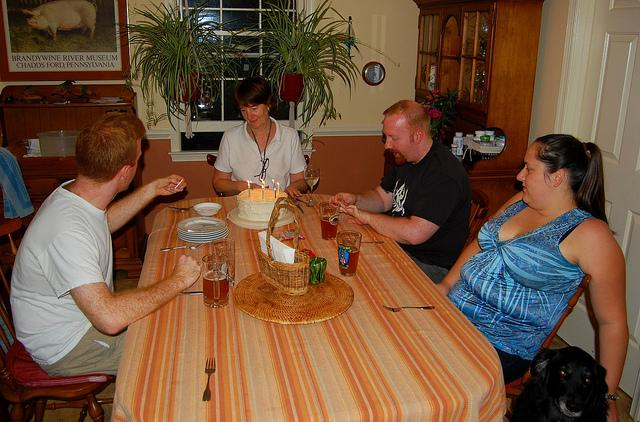Why are there candles in the cake in front of the woman? Please explain your reasoning. her birthday. Candles are usually used for birthday celebrations. 